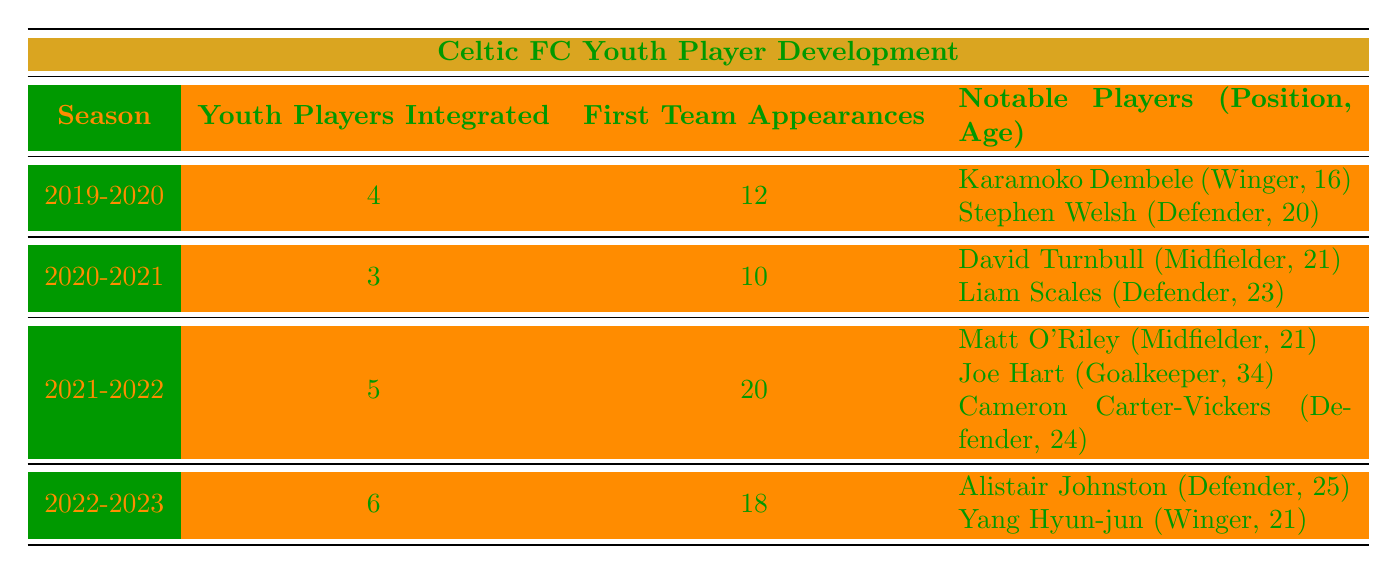What season had the highest number of youth players integrated? The table shows the number of youth players integrated per season. The season with the highest number is 2022-2023, with 6 youth players integrated.
Answer: 2022-2023 What were the total first team appearances for youth players from 2019-2020 to 2022-2023? To find the total, sum the first team appearances: 12 (2019-2020) + 10 (2020-2021) + 20 (2021-2022) + 18 (2022-2023) = 60.
Answer: 60 Did Celtic FC integrate more than 4 youth players in the 2021-2022 season? In the 2021-2022 season, the table shows that 5 youth players were integrated, which is more than 4.
Answer: Yes Who was the youngest player integrated in the 2019-2020 season? In the 2019-2020 season, Karamoko Dembele, aged 16, was the youngest player integrated, according to the table data.
Answer: Karamoko Dembele What is the average age of notable players integrated during the 2020-2021 season? The notable players in the 2020-2021 season were David Turnbull (21) and Liam Scales (23). To find the average: (21 + 23) / 2 = 22.
Answer: 22 Was there any season where the first team appearances were less than 10? According to the table, the seasons 2019-2020 (12) and 2020-2021 (10) had 10 appearances but none had less than 10, so the answer is no.
Answer: No Which position had the most players integrated in the notable players list across all seasons? By reviewing the table, we find that "Defender" appears multiple times (Stephen Welsh, Liam Scales, Cameron Carter-Vickers, Alistair Johnston), outnumbering any other position.
Answer: Defender In which season did players aged 25 and older get integrated into the first team? The only player aged 25 or older integrated was Alistair Johnston in the 2022-2023 season, indicating this is the season in question.
Answer: 2022-2023 